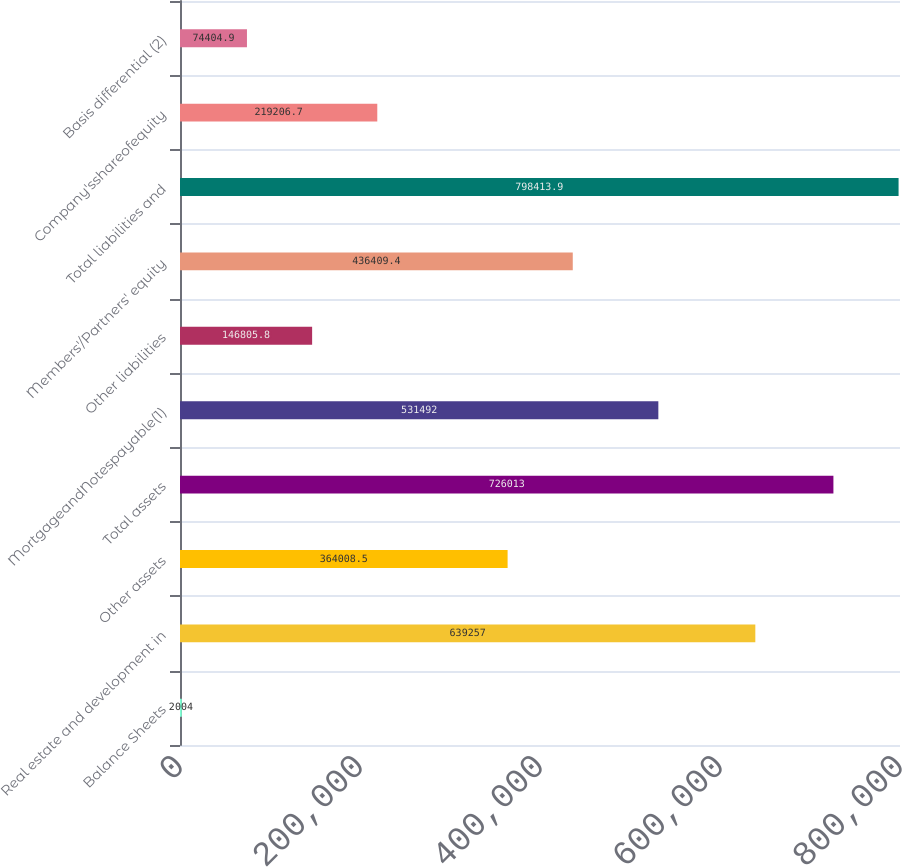<chart> <loc_0><loc_0><loc_500><loc_500><bar_chart><fcel>Balance Sheets<fcel>Real estate and development in<fcel>Other assets<fcel>Total assets<fcel>MortgageandNotespayable(1)<fcel>Other liabilities<fcel>Members'/Partners' equity<fcel>Total liabilities and<fcel>Company'sshareofequity<fcel>Basis differential (2)<nl><fcel>2004<fcel>639257<fcel>364008<fcel>726013<fcel>531492<fcel>146806<fcel>436409<fcel>798414<fcel>219207<fcel>74404.9<nl></chart> 